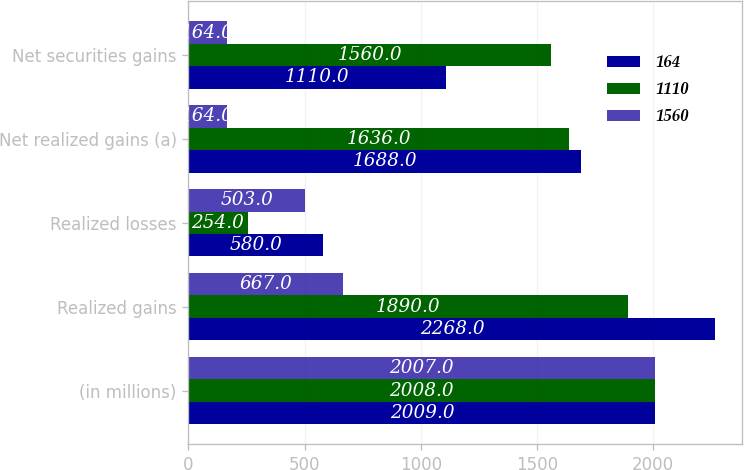Convert chart to OTSL. <chart><loc_0><loc_0><loc_500><loc_500><stacked_bar_chart><ecel><fcel>(in millions)<fcel>Realized gains<fcel>Realized losses<fcel>Net realized gains (a)<fcel>Net securities gains<nl><fcel>164<fcel>2009<fcel>2268<fcel>580<fcel>1688<fcel>1110<nl><fcel>1110<fcel>2008<fcel>1890<fcel>254<fcel>1636<fcel>1560<nl><fcel>1560<fcel>2007<fcel>667<fcel>503<fcel>164<fcel>164<nl></chart> 